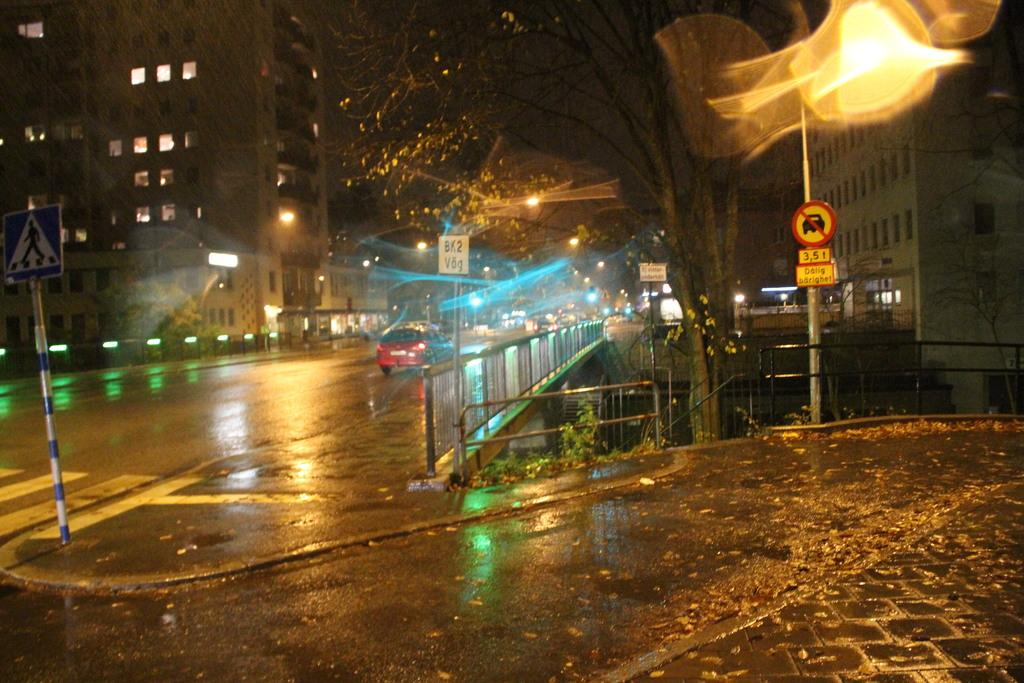What is on the road in the image? There is a vehicle on the road in the image. What is the condition of the road? The road appears to be wet in the image. What structures can be seen in the image? There is a pole, a board, a fence, and buildings in the image. What is the purpose of the board in the image? The board's purpose cannot be determined from the image alone. What is the condition of the grass in the image? There is grass in the image, but its condition cannot be determined from the image alone. What is the purpose of the lights in the image? The purpose of the lights in the image cannot be determined from the image alone. What is the condition of the trees in the image? There are trees in the image, but their condition cannot be determined from the image alone. What type of coat is hanging on the fence in the image? There is no coat present in the image. What is the waste management system like in the image? There is no information about waste management in the image. 